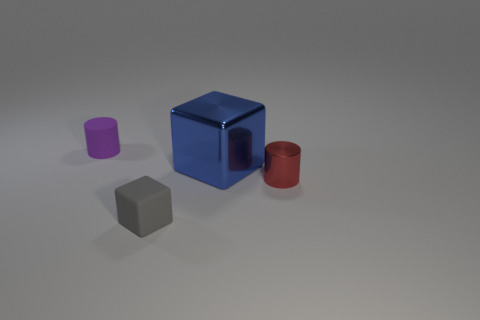What could the setting imply about the purpose of these objects? The simplistic setting and the presence of basic geometrical shapes suggest a controlled environment, possibly for illustrative or educational purposes, where the focus is on the properties of the objects like shape and color rather than their functionality. 